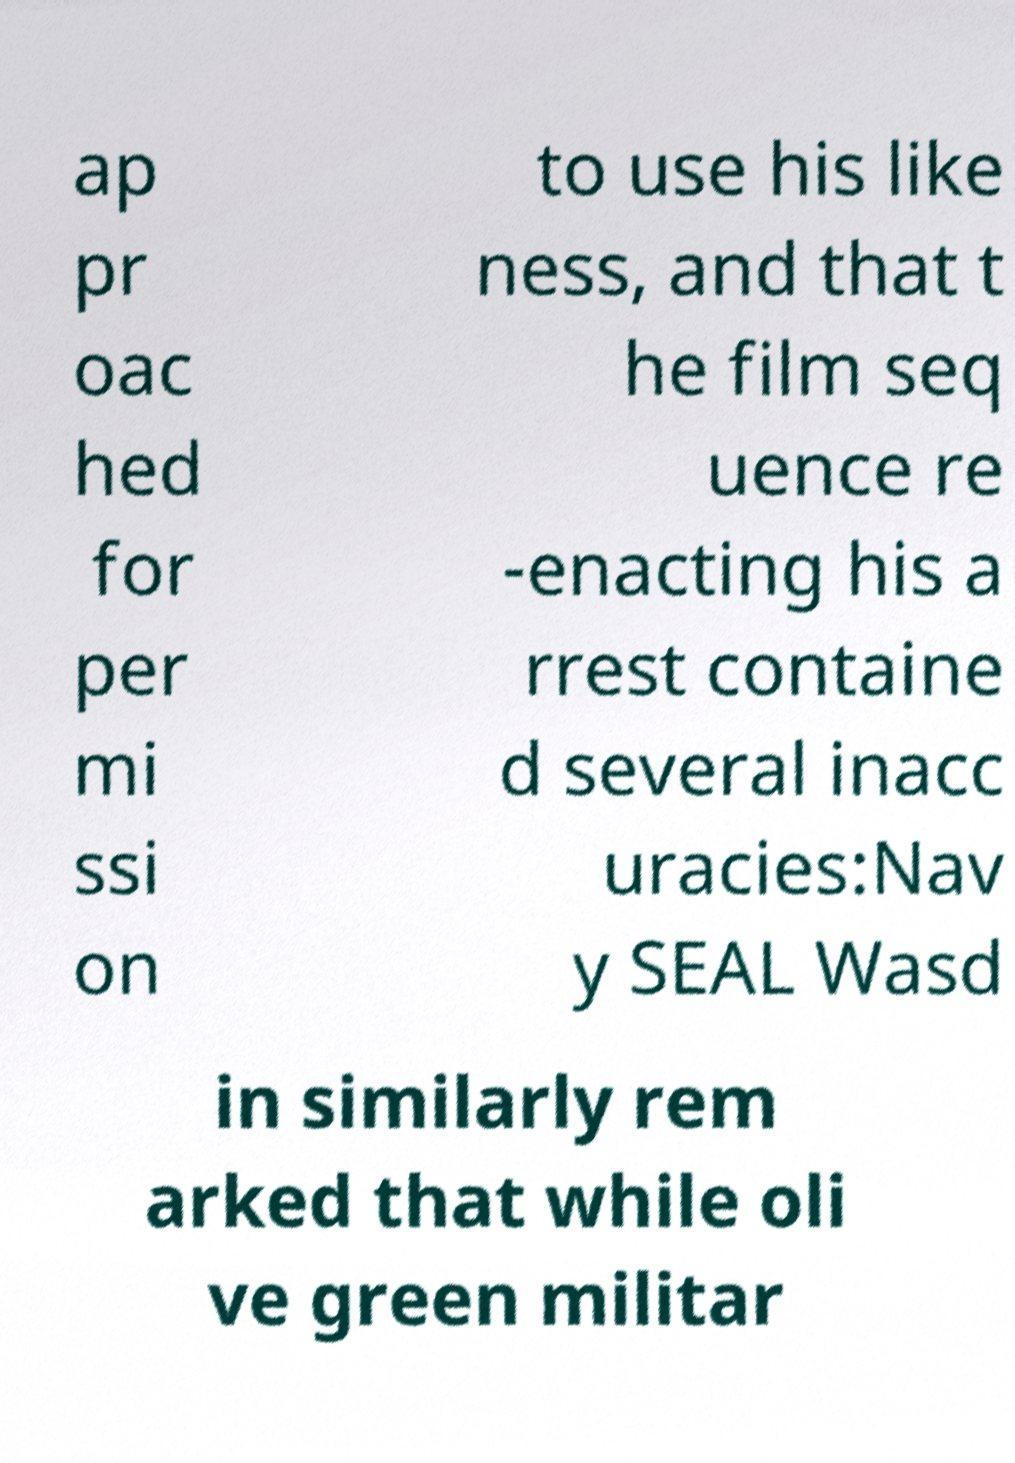Please identify and transcribe the text found in this image. ap pr oac hed for per mi ssi on to use his like ness, and that t he film seq uence re -enacting his a rrest containe d several inacc uracies:Nav y SEAL Wasd in similarly rem arked that while oli ve green militar 